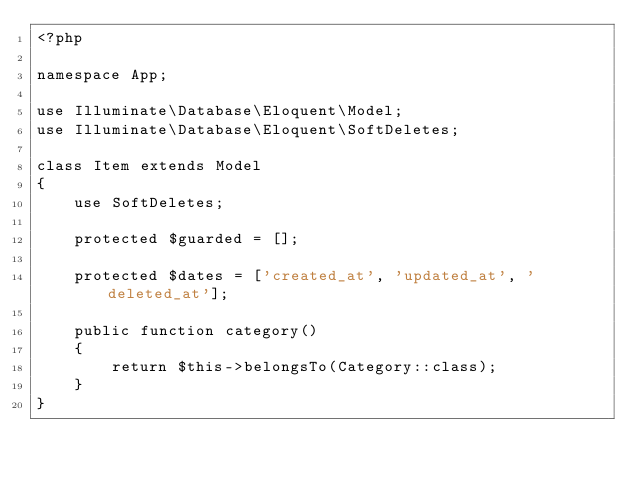<code> <loc_0><loc_0><loc_500><loc_500><_PHP_><?php

namespace App;

use Illuminate\Database\Eloquent\Model;
use Illuminate\Database\Eloquent\SoftDeletes;

class Item extends Model
{
    use SoftDeletes;

    protected $guarded = [];

    protected $dates = ['created_at', 'updated_at', 'deleted_at'];

    public function category()
    {
        return $this->belongsTo(Category::class);
    }
}
</code> 